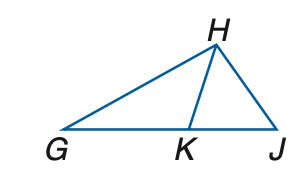Answer the mathemtical geometry problem and directly provide the correct option letter.
Question: In the figure, G K \cong G H and H K \cong K J. If m \angle H G K = 42, find m \angle H J K.
Choices: A: 34.5 B: 39.5 C: 42 D: 48 A 